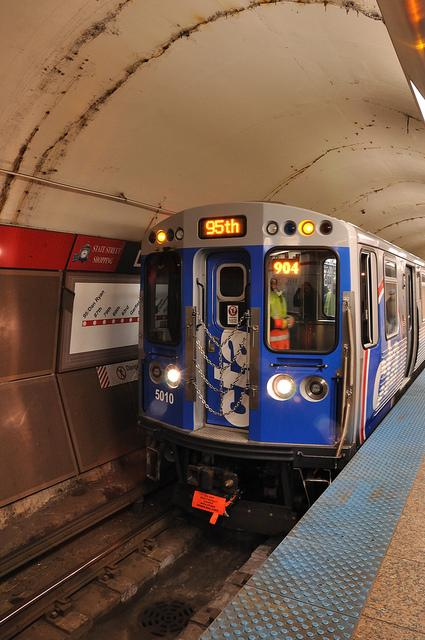In what US city is this subway station located in? Please explain your reasoning. chicago. The subway station is in chicago based on the sign's locations. 